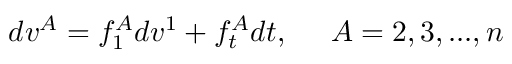<formula> <loc_0><loc_0><loc_500><loc_500>d v ^ { A } = f _ { 1 } ^ { A } d v ^ { 1 } + f _ { t } ^ { A } d t , \, A = 2 , 3 , \dots , n</formula> 